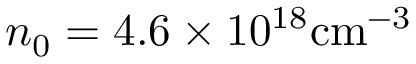<formula> <loc_0><loc_0><loc_500><loc_500>n _ { 0 } = 4 . 6 \times 1 0 ^ { 1 8 } { c m ^ { - 3 } }</formula> 